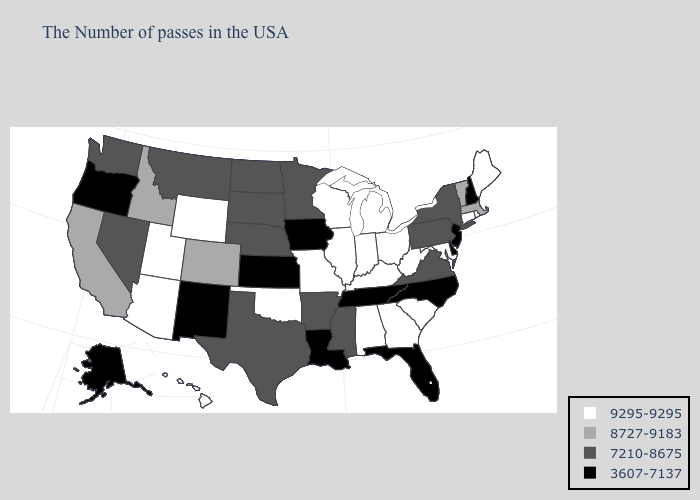Among the states that border New Jersey , does Delaware have the highest value?
Write a very short answer. No. Name the states that have a value in the range 7210-8675?
Keep it brief. New York, Pennsylvania, Virginia, Mississippi, Arkansas, Minnesota, Nebraska, Texas, South Dakota, North Dakota, Montana, Nevada, Washington. Does Georgia have the lowest value in the USA?
Give a very brief answer. No. Does Texas have a lower value than Indiana?
Write a very short answer. Yes. Name the states that have a value in the range 3607-7137?
Keep it brief. New Hampshire, New Jersey, Delaware, North Carolina, Florida, Tennessee, Louisiana, Iowa, Kansas, New Mexico, Oregon, Alaska. What is the highest value in states that border Kansas?
Keep it brief. 9295-9295. What is the highest value in states that border Washington?
Concise answer only. 8727-9183. What is the lowest value in the USA?
Write a very short answer. 3607-7137. What is the value of Delaware?
Give a very brief answer. 3607-7137. Name the states that have a value in the range 8727-9183?
Quick response, please. Massachusetts, Vermont, Colorado, Idaho, California. Does Kentucky have the same value as South Dakota?
Answer briefly. No. Name the states that have a value in the range 3607-7137?
Keep it brief. New Hampshire, New Jersey, Delaware, North Carolina, Florida, Tennessee, Louisiana, Iowa, Kansas, New Mexico, Oregon, Alaska. Name the states that have a value in the range 7210-8675?
Concise answer only. New York, Pennsylvania, Virginia, Mississippi, Arkansas, Minnesota, Nebraska, Texas, South Dakota, North Dakota, Montana, Nevada, Washington. Does the first symbol in the legend represent the smallest category?
Short answer required. No. What is the value of Montana?
Write a very short answer. 7210-8675. 